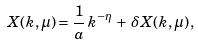<formula> <loc_0><loc_0><loc_500><loc_500>X ( { k } , \mu ) = \frac { 1 } { a } \, k ^ { - \eta } \, + \, \delta X ( { k } , \mu ) \, ,</formula> 